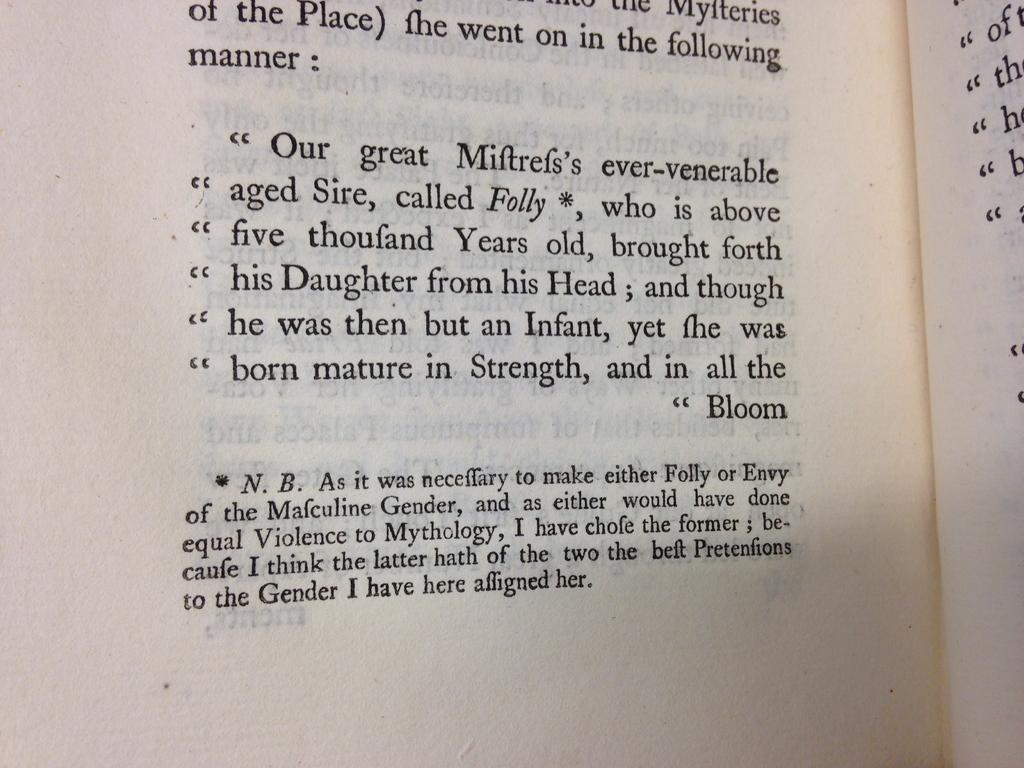<image>
Provide a brief description of the given image. A book is open to a passage that begins "Our great Miftref's ever-venerable aged Sire, called Folly, who is above five thoufand Years old". 